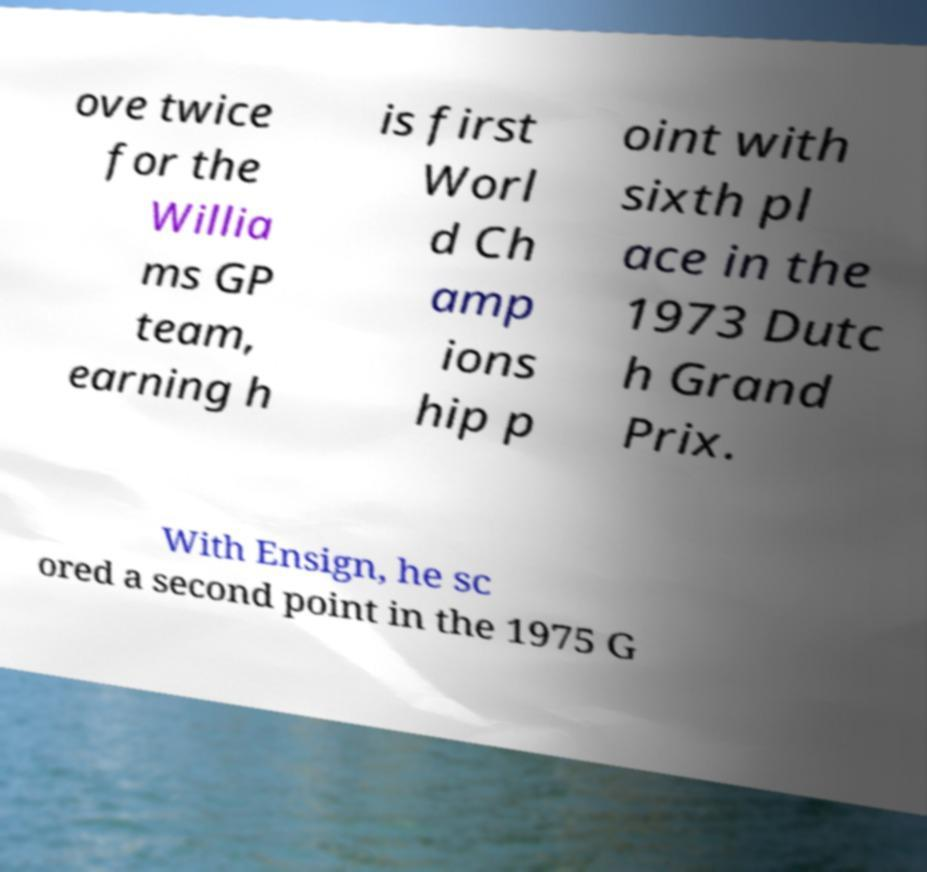I need the written content from this picture converted into text. Can you do that? ove twice for the Willia ms GP team, earning h is first Worl d Ch amp ions hip p oint with sixth pl ace in the 1973 Dutc h Grand Prix. With Ensign, he sc ored a second point in the 1975 G 